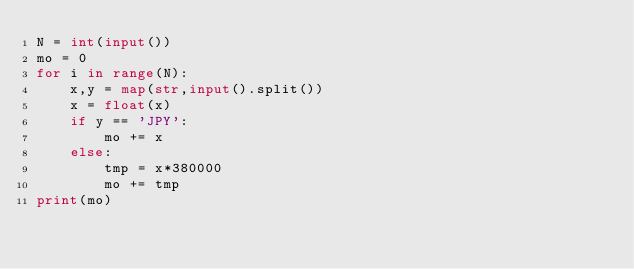Convert code to text. <code><loc_0><loc_0><loc_500><loc_500><_Python_>N = int(input())
mo = 0
for i in range(N):
    x,y = map(str,input().split())
    x = float(x)
    if y == 'JPY':
        mo += x
    else:
        tmp = x*380000
        mo += tmp
print(mo)</code> 